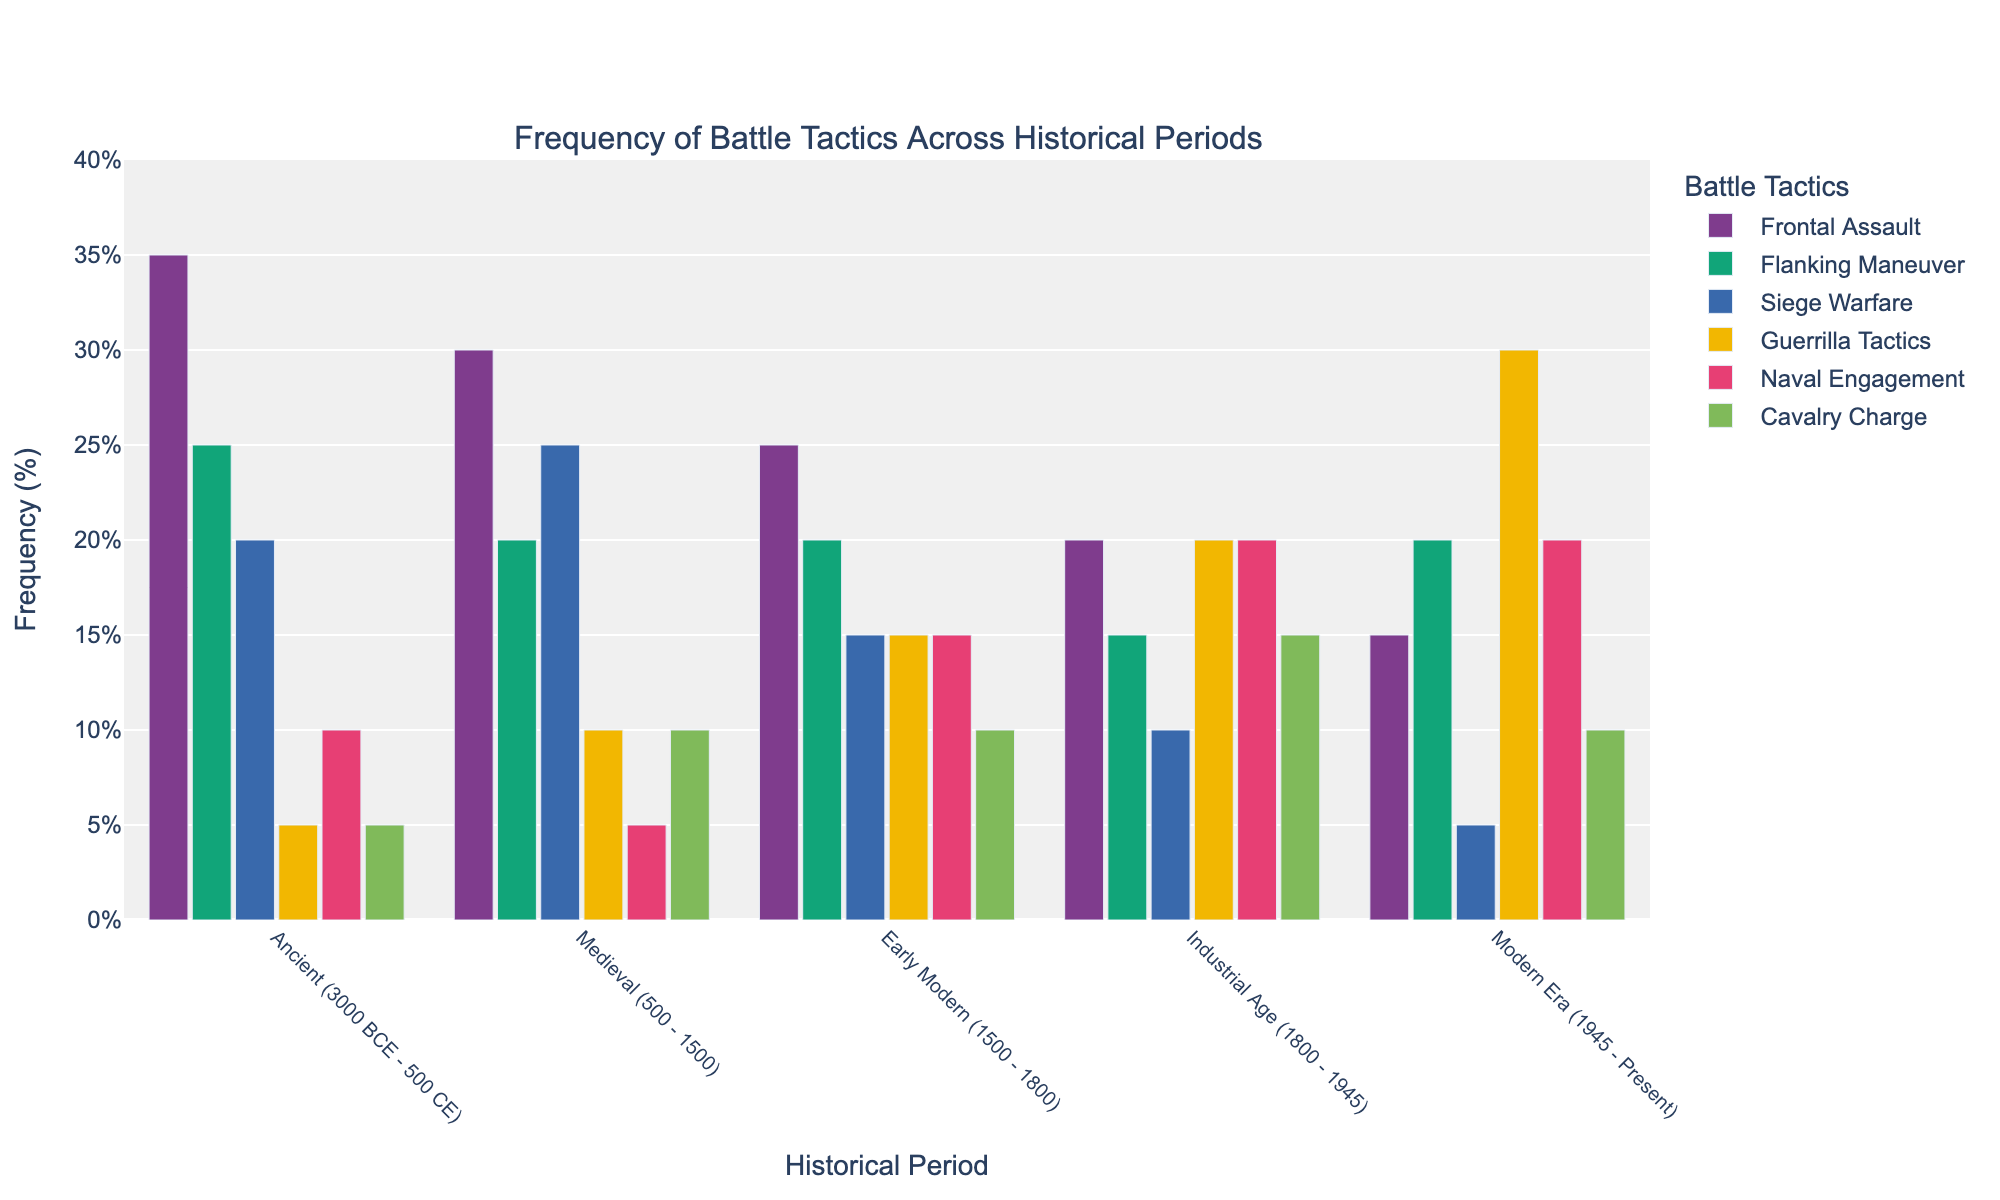Which historical period used Guerrilla Tactics the most? By looking at the heights of the bars corresponding to Guerrilla Tactics for each period, we see that the Modern Era has the tallest bar. This indicates that Guerrilla Tactics were used most frequently during the Modern Era.
Answer: Modern Era During which period was Siege Warfare most frequent? By comparing the heights of the bars for Siege Warfare across all periods, the Medieval period has the highest bar. This shows that Siege Warfare was most frequent during the Medieval period.
Answer: Medieval How does the frequency of Naval Engagement compare between the Early Modern and Industrial Age periods? The heights of the bars for Naval Engagement in the Early Modern and Industrial Age periods show that both bars are equal. This means the frequency of Naval Engagement is the same in these periods.
Answer: Equal What is the sum of frequencies for Cavalry Charge during the Ancient and Medieval periods? The frequencies for Cavalry Charge are 5 for the Ancient period and 10 for the Medieval period. Adding these together, we get 5 + 10 = 15.
Answer: 15 By how much did the use of Frontal Assault tactics decrease from the Ancient period to the Modern Era? The frequency of Frontal Assault is 35 in the Ancient period and 15 in the Modern Era. The decrease is 35 - 15 = 20.
Answer: 20 Which tactic showed the greatest increase in frequency from the Early Modern period to the Modern Era? By comparing the differences in bar heights across tactics between the Early Modern and Modern Era periods, Guerrilla Tactics increased from 15 to 30. This is an increase of 30 - 15 = 15.
Answer: Guerrilla Tactics During which period did Flanking Maneuver have the highest frequency? By observing the heights of the bars corresponding to Flanking Maneuver, we see that the Modern Era has the highest frequency with a bar height of 20.
Answer: Modern Era How many tactics had a frequency greater than 15% during the Industrial Age period? Examining the bars for the Industrial Age period, we find that Guerrilla Tactics (20%), Naval Engagement (20%), and Cavalry Charge (15%) are greater than 15%. So, there are three tactics.
Answer: 3 What’s the average frequency of Siege Warfare across all periods? The frequencies for Siege Warfare are 20 (Ancient), 25 (Medieval), 15 (Early Modern), 10 (Industrial Age), and 5 (Modern). Adding these, we get 20 + 25 + 15 + 10 + 5 = 75, dividing by 5 periods, we get 75 / 5 = 15.
Answer: 15 Which period had the least use of Frontal Assault tactics and what was its frequency? By finding the shortest bar for Frontal Assault across all periods, we see that the Modern Era has the least use, with a frequency of 15.
Answer: Modern Era, 15 